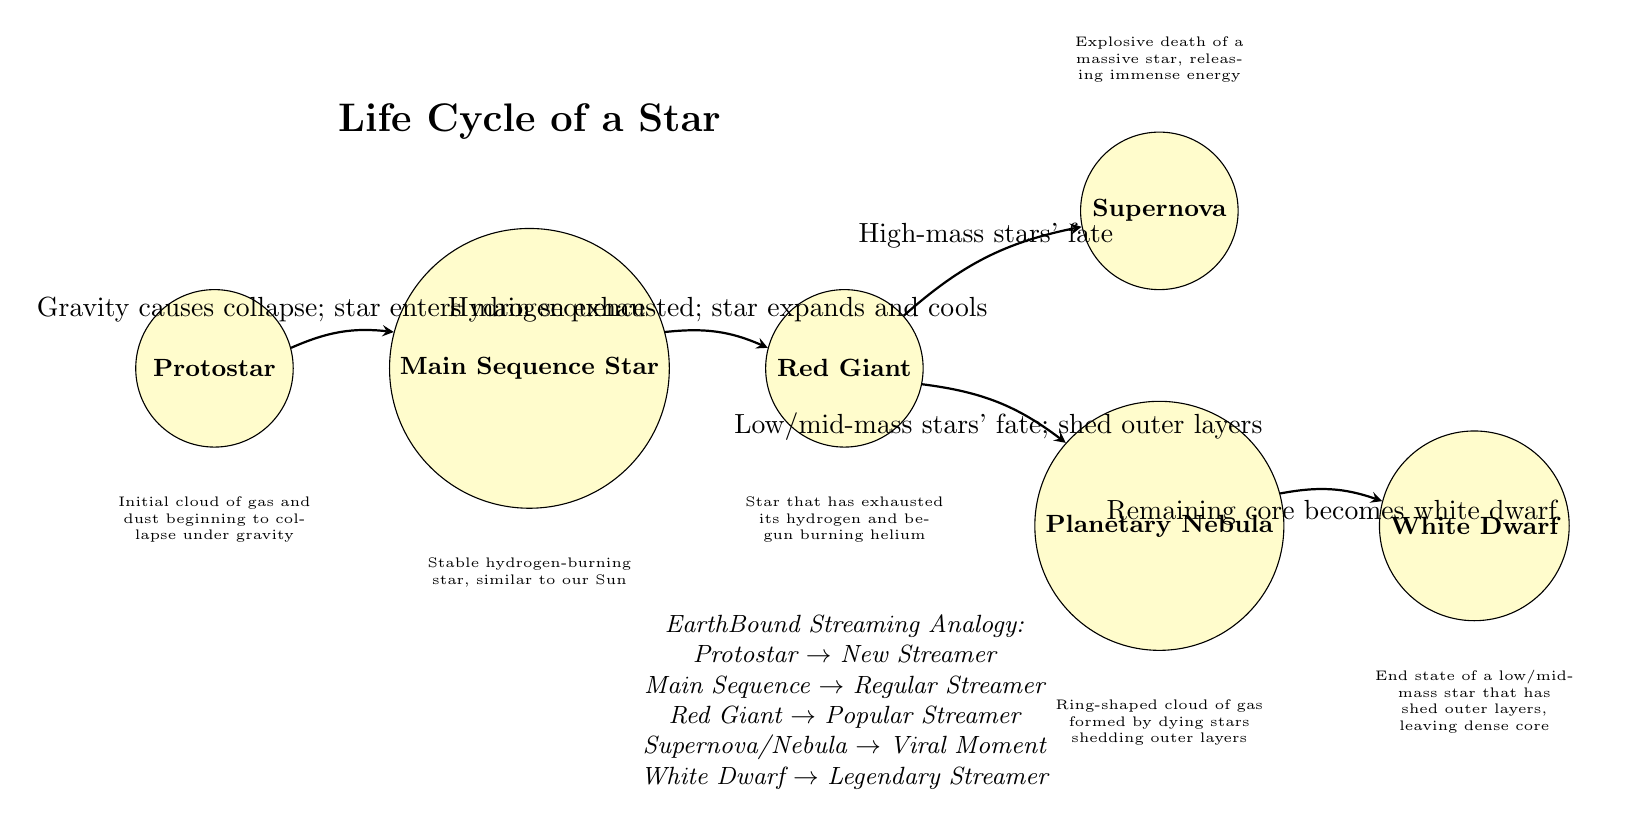What is the first stage in the life cycle of a star? The diagram lists "Protostar" as the first stage in the life cycle of a star, positioned at the leftmost node.
Answer: Protostar How many stages are there in the life cycle of a star? Counting the nodes in the diagram, there are a total of six stages: Protostar, Main Sequence Star, Red Giant, Supernova, Planetary Nebula, and White Dwarf.
Answer: 6 What transition occurs from Main Sequence Star to Red Giant? The diagram indicates that the transition occurs when hydrogen is exhausted, leading the star to expand and cool.
Answer: Hydrogen exhausted; star expands and cools Which stage is analogous to a "Viral Moment"? According to the EarthBound analogy section of the diagram, "Supernova" and "Nebula" are collectively referred to as representing a "Viral Moment".
Answer: Supernova/Nebula What follows the Red Giant stage in the life cycle of a high-mass star? The diagram shows that a high-mass star that becomes a Red Giant will transition into a "Supernova".
Answer: Supernova What is the final state of a low/mid-mass star after shedding outer layers? From the diagram, the final state of a low/mid-mass star is depicted as a "White Dwarf", which is the last node indicated.
Answer: White Dwarf Which node represents the analogy for "New Streamer"? The diagram uses "Protostar" to represent the analogy for "New Streamer".
Answer: Protostar How does a Red Giant star's fate differ based on mass? The diagram expresses that a Red Giant's fate will lead to either a Supernova in high-mass stars or a Planetary Nebula in low/mid-mass stars, demonstrating the difference based on mass.
Answer: High-mass: Supernova; Low/mid-mass: Nebula 